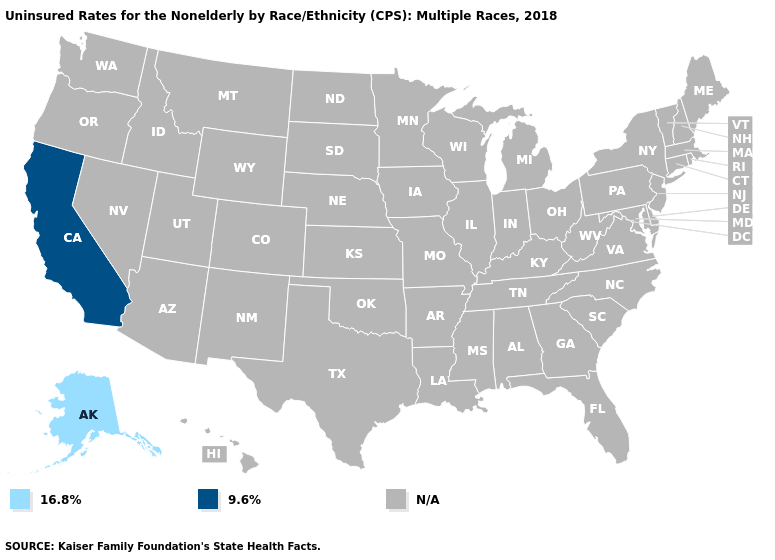What is the highest value in the USA?
Answer briefly. 9.6%. Does Alaska have the highest value in the USA?
Concise answer only. No. What is the value of New Hampshire?
Quick response, please. N/A. Does Alaska have the lowest value in the USA?
Answer briefly. Yes. What is the value of Alabama?
Answer briefly. N/A. How many symbols are there in the legend?
Quick response, please. 3. What is the lowest value in the USA?
Be succinct. 16.8%. What is the value of Iowa?
Quick response, please. N/A. What is the value of Utah?
Concise answer only. N/A. Name the states that have a value in the range N/A?
Short answer required. Alabama, Arizona, Arkansas, Colorado, Connecticut, Delaware, Florida, Georgia, Hawaii, Idaho, Illinois, Indiana, Iowa, Kansas, Kentucky, Louisiana, Maine, Maryland, Massachusetts, Michigan, Minnesota, Mississippi, Missouri, Montana, Nebraska, Nevada, New Hampshire, New Jersey, New Mexico, New York, North Carolina, North Dakota, Ohio, Oklahoma, Oregon, Pennsylvania, Rhode Island, South Carolina, South Dakota, Tennessee, Texas, Utah, Vermont, Virginia, Washington, West Virginia, Wisconsin, Wyoming. 